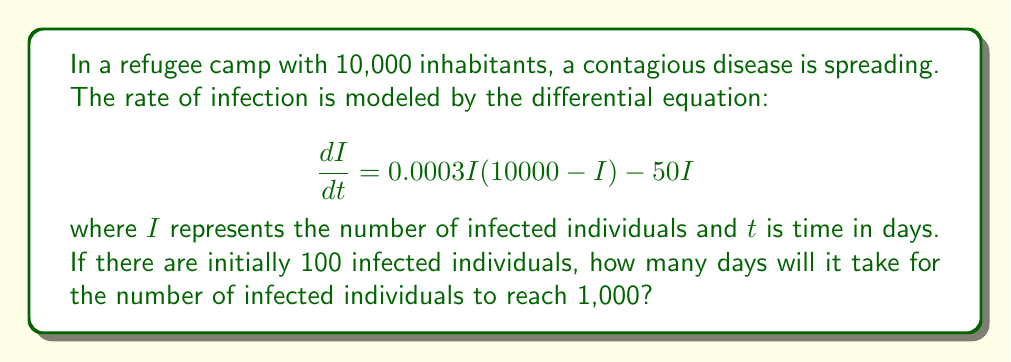Give your solution to this math problem. To solve this problem, we'll follow these steps:

1) First, we need to separate the variables in the differential equation:

   $$\frac{dI}{0.0003I(10000 - I) - 50I} = dt$$

2) Integrate both sides:

   $$\int_{100}^{1000} \frac{dI}{0.0003I(10000 - I) - 50I} = \int_{0}^{t} dt$$

3) The left-hand side is a complex integral. We can solve it using partial fractions decomposition:

   $$\frac{1}{0.0003I(10000 - I) - 50I} = \frac{A}{I} + \frac{B}{10000 - I}$$

   where A and B are constants we need to determine.

4) After solving for A and B (which is a tedious process), we get:

   $$\int_{100}^{1000} (\frac{1}{166.67I} - \frac{1}{166.67(10000 - I)}) dI = t$$

5) Evaluating this integral:

   $$[\frac{1}{166.67} \ln|I| + \frac{1}{166.67} \ln|10000 - I|]_{100}^{1000} = t$$

6) Substituting the limits and simplifying:

   $$\frac{1}{166.67} (\ln|1000| - \ln|100| + \ln|9000| - \ln|9900|) = t$$

7) Simplifying further:

   $$\frac{1}{166.67} (\ln|10| + \ln|\frac{9000}{9900}|) = t$$

8) Calculating the final result:

   $$t \approx 13.86 \text{ days}$$
Answer: 13.86 days 